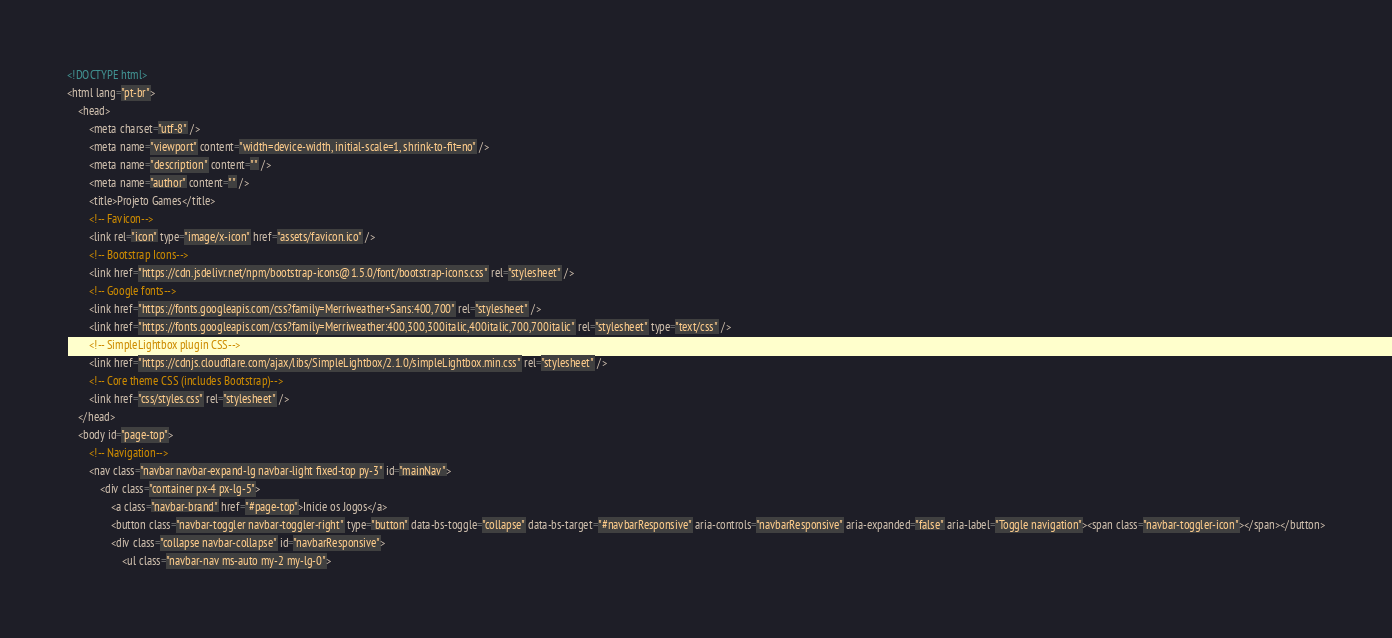<code> <loc_0><loc_0><loc_500><loc_500><_HTML_><!DOCTYPE html>
<html lang="pt-br">
    <head>
        <meta charset="utf-8" />
        <meta name="viewport" content="width=device-width, initial-scale=1, shrink-to-fit=no" />
        <meta name="description" content="" />
        <meta name="author" content="" />
        <title>Projeto Games</title>
        <!-- Favicon-->
        <link rel="icon" type="image/x-icon" href="assets/favicon.ico" />
        <!-- Bootstrap Icons-->
        <link href="https://cdn.jsdelivr.net/npm/bootstrap-icons@1.5.0/font/bootstrap-icons.css" rel="stylesheet" />
        <!-- Google fonts-->
        <link href="https://fonts.googleapis.com/css?family=Merriweather+Sans:400,700" rel="stylesheet" />
        <link href="https://fonts.googleapis.com/css?family=Merriweather:400,300,300italic,400italic,700,700italic" rel="stylesheet" type="text/css" />
        <!-- SimpleLightbox plugin CSS-->
        <link href="https://cdnjs.cloudflare.com/ajax/libs/SimpleLightbox/2.1.0/simpleLightbox.min.css" rel="stylesheet" />
        <!-- Core theme CSS (includes Bootstrap)-->
        <link href="css/styles.css" rel="stylesheet" />
    </head>
    <body id="page-top">
        <!-- Navigation-->
        <nav class="navbar navbar-expand-lg navbar-light fixed-top py-3" id="mainNav">
            <div class="container px-4 px-lg-5">
                <a class="navbar-brand" href="#page-top">Inicie os Jogos</a>
                <button class="navbar-toggler navbar-toggler-right" type="button" data-bs-toggle="collapse" data-bs-target="#navbarResponsive" aria-controls="navbarResponsive" aria-expanded="false" aria-label="Toggle navigation"><span class="navbar-toggler-icon"></span></button>
                <div class="collapse navbar-collapse" id="navbarResponsive">
                    <ul class="navbar-nav ms-auto my-2 my-lg-0"></code> 